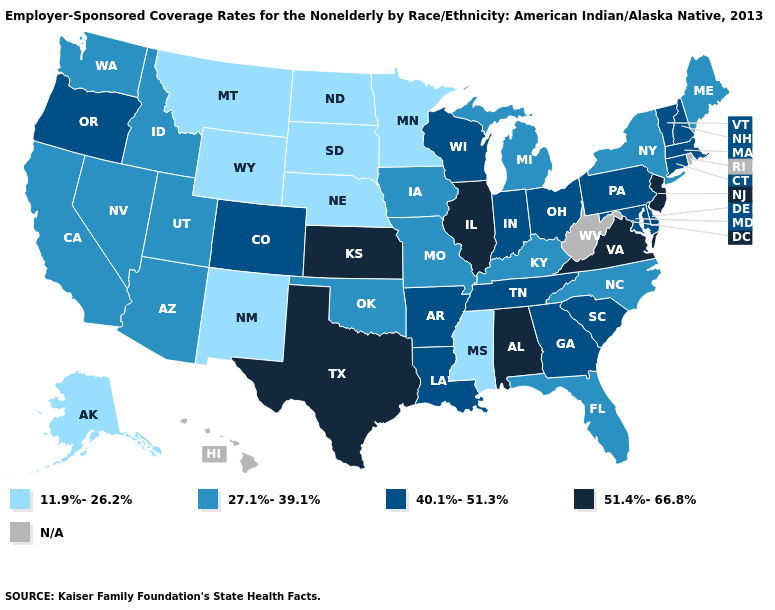What is the lowest value in the MidWest?
Give a very brief answer. 11.9%-26.2%. What is the highest value in states that border Virginia?
Concise answer only. 40.1%-51.3%. Among the states that border Pennsylvania , does Maryland have the lowest value?
Be succinct. No. Name the states that have a value in the range 51.4%-66.8%?
Write a very short answer. Alabama, Illinois, Kansas, New Jersey, Texas, Virginia. What is the value of West Virginia?
Short answer required. N/A. Name the states that have a value in the range N/A?
Concise answer only. Hawaii, Rhode Island, West Virginia. What is the highest value in the USA?
Quick response, please. 51.4%-66.8%. What is the value of New York?
Write a very short answer. 27.1%-39.1%. What is the value of Tennessee?
Short answer required. 40.1%-51.3%. 